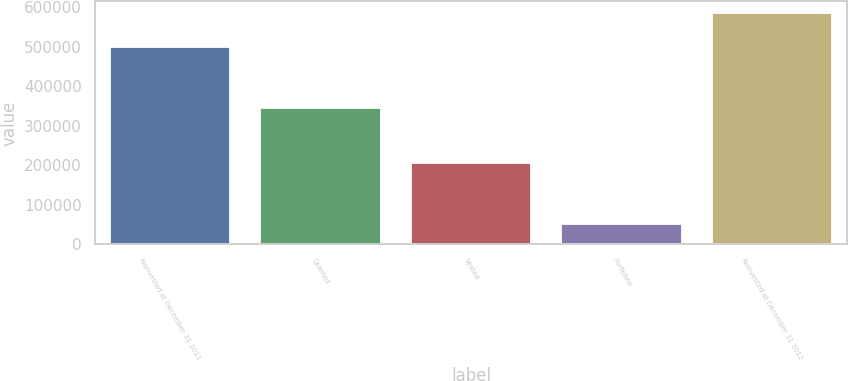Convert chart to OTSL. <chart><loc_0><loc_0><loc_500><loc_500><bar_chart><fcel>Nonvested at December 31 2011<fcel>Granted<fcel>Vested<fcel>Forfeited<fcel>Nonvested at December 31 2012<nl><fcel>499119<fcel>343997<fcel>205933<fcel>51640<fcel>585543<nl></chart> 